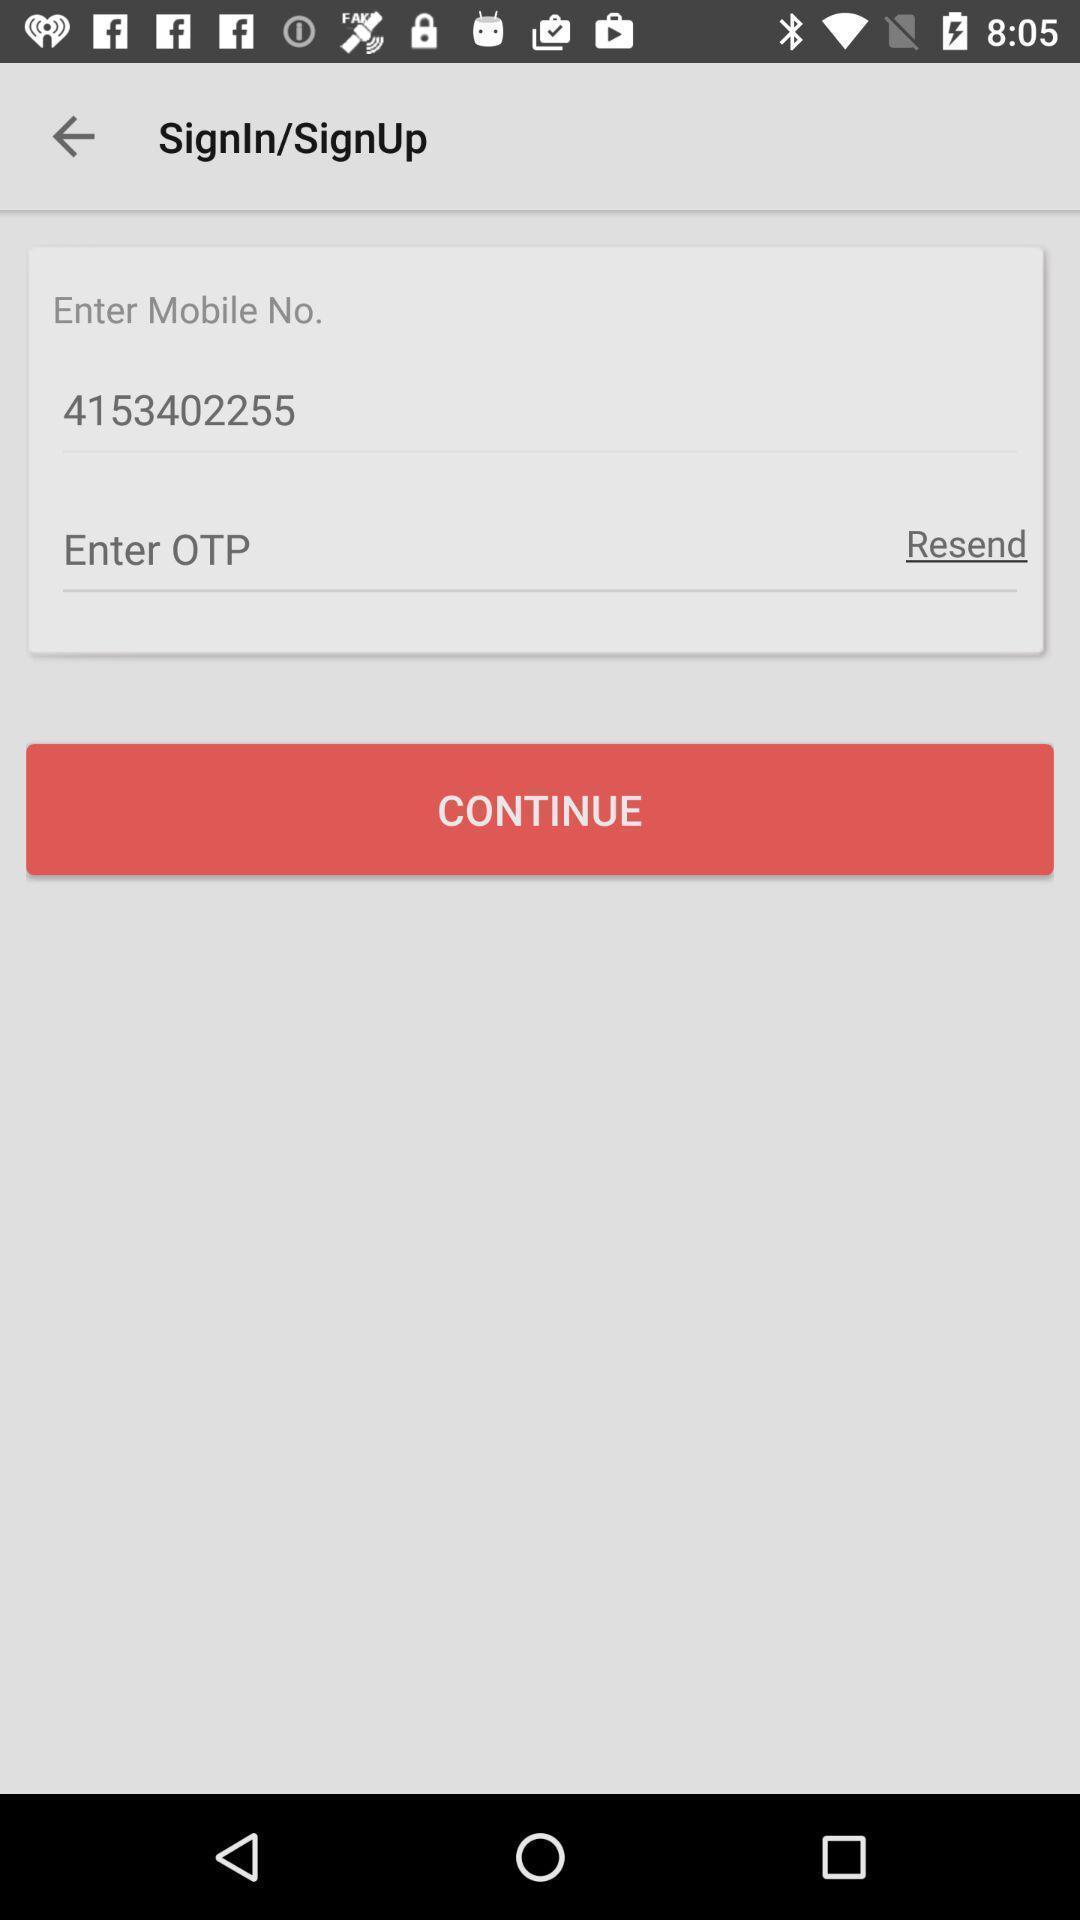Provide a textual representation of this image. Sign up page for an app using mobile number. 